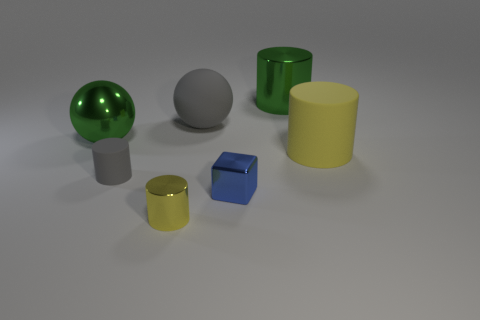Do the small blue object and the gray object in front of the big matte cylinder have the same shape?
Your response must be concise. No. What is the blue object made of?
Give a very brief answer. Metal. There is a metallic thing that is the same shape as the big gray matte object; what is its size?
Give a very brief answer. Large. What number of other things are the same material as the blue cube?
Your answer should be compact. 3. Are the small blue cube and the object that is right of the green metallic cylinder made of the same material?
Give a very brief answer. No. Are there fewer blue metallic objects behind the tiny gray object than large yellow matte cylinders that are left of the green cylinder?
Your answer should be very brief. No. What is the color of the metallic cylinder that is in front of the yellow matte cylinder?
Provide a short and direct response. Yellow. What number of other objects are the same color as the large rubber cylinder?
Your answer should be compact. 1. There is a green object that is to the left of the gray rubber sphere; is its size the same as the green shiny cylinder?
Provide a short and direct response. Yes. How many small gray cylinders are on the left side of the yellow metal cylinder?
Make the answer very short. 1. 